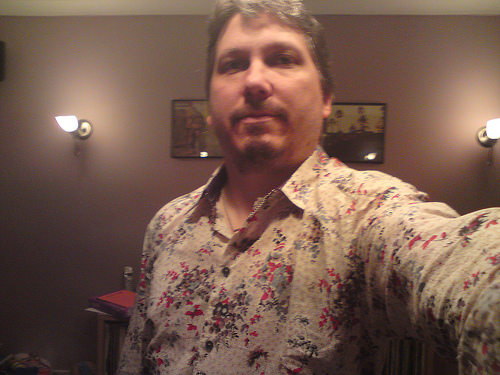<image>
Is the wall in front of the man? No. The wall is not in front of the man. The spatial positioning shows a different relationship between these objects. 